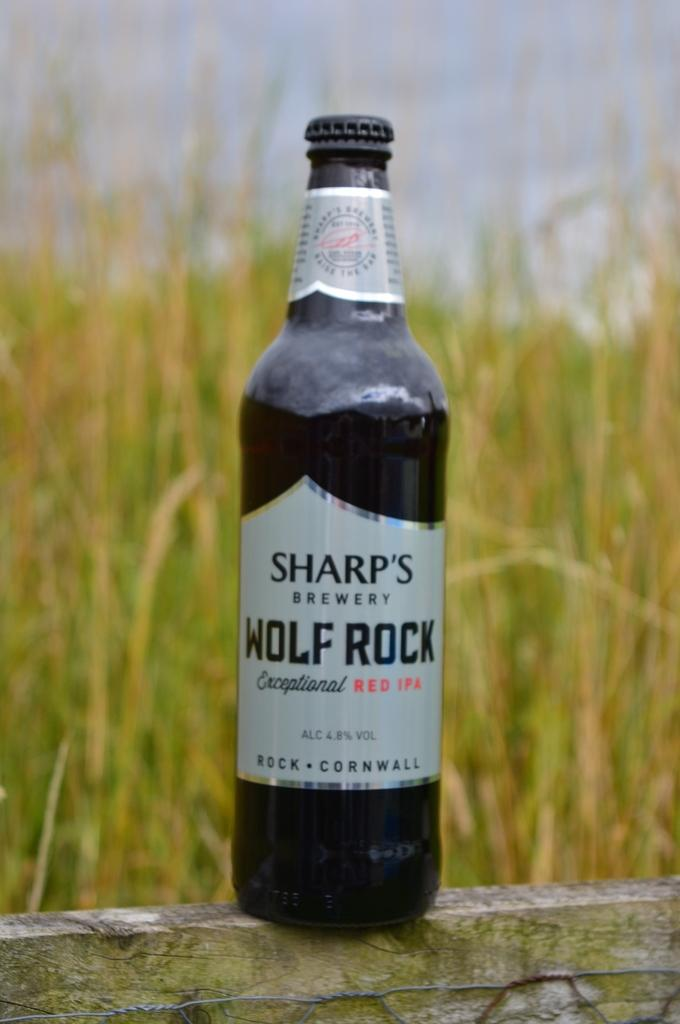<image>
Describe the image concisely. a bottle of sharps brewery beer wolf rock on a stone wall 